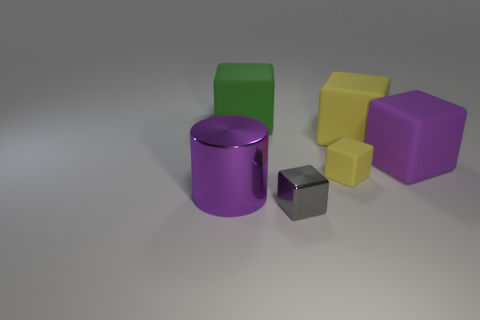There is a big thing that is the same color as the cylinder; what is its material?
Provide a succinct answer. Rubber. There is a big yellow thing; are there any big cylinders behind it?
Make the answer very short. No. Are the tiny thing in front of the purple cylinder and the purple object that is left of the big green block made of the same material?
Your response must be concise. Yes. Are there fewer big green matte blocks that are behind the large metal cylinder than purple objects?
Make the answer very short. Yes. What color is the metallic thing that is behind the gray thing?
Your response must be concise. Purple. There is a small thing in front of the purple object left of the large yellow matte object; what is its material?
Your response must be concise. Metal. Is there a gray metallic block of the same size as the green rubber thing?
Offer a very short reply. No. How many objects are either matte cubes in front of the green block or matte cubes behind the shiny cylinder?
Give a very brief answer. 4. There is a matte cube that is to the left of the tiny yellow rubber cube; does it have the same size as the purple object that is to the right of the small gray metallic block?
Provide a succinct answer. Yes. Is there a big purple object to the right of the yellow rubber thing in front of the large yellow rubber object?
Offer a terse response. Yes. 